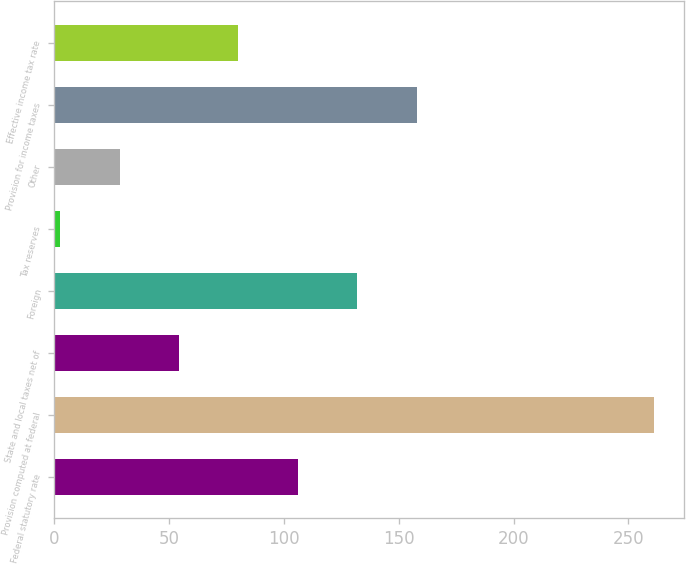Convert chart to OTSL. <chart><loc_0><loc_0><loc_500><loc_500><bar_chart><fcel>Federal statutory rate<fcel>Provision computed at federal<fcel>State and local taxes net of<fcel>Foreign<fcel>Tax reserves<fcel>Other<fcel>Provision for income taxes<fcel>Effective income tax rate<nl><fcel>106.02<fcel>261.3<fcel>54.26<fcel>131.9<fcel>2.5<fcel>28.38<fcel>157.78<fcel>80.14<nl></chart> 